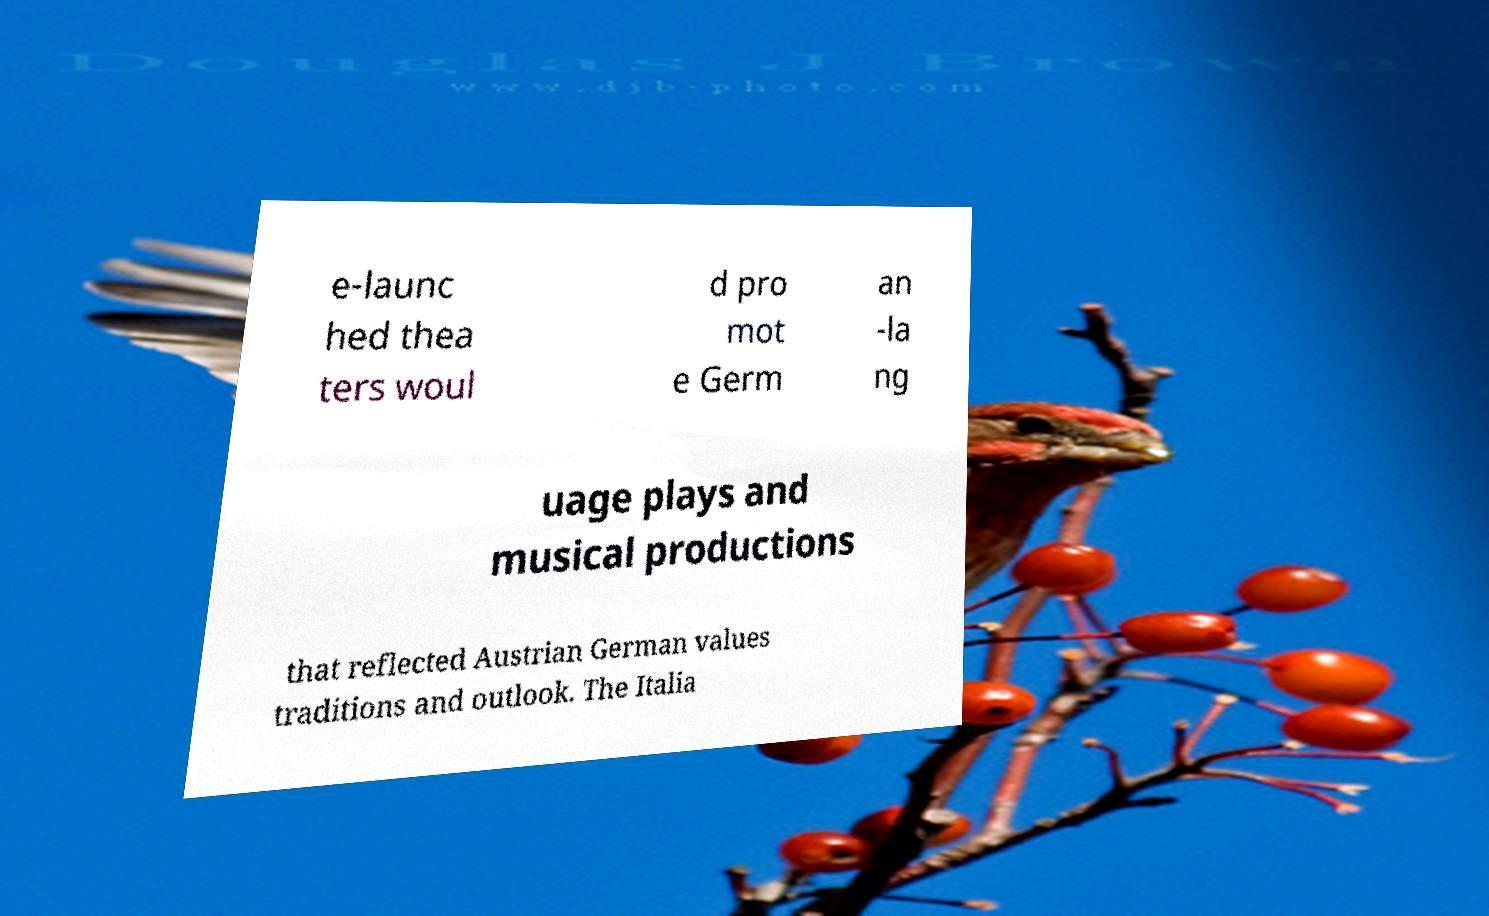Could you assist in decoding the text presented in this image and type it out clearly? e-launc hed thea ters woul d pro mot e Germ an -la ng uage plays and musical productions that reflected Austrian German values traditions and outlook. The Italia 